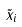<formula> <loc_0><loc_0><loc_500><loc_500>\tilde { x } _ { i }</formula> 